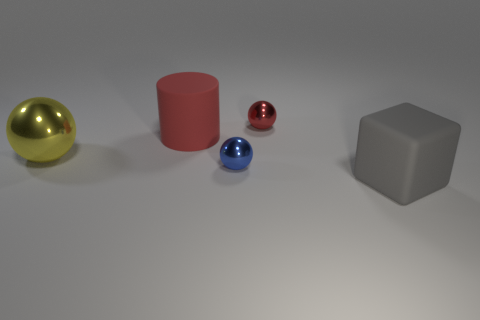There is a tiny object that is the same color as the cylinder; what is it made of?
Offer a very short reply. Metal. Are there any shiny balls that have the same color as the big rubber cylinder?
Keep it short and to the point. Yes. There is a large matte thing behind the yellow metallic sphere; what color is it?
Offer a terse response. Red. Is there a block that is on the right side of the metal sphere behind the rubber cylinder?
Keep it short and to the point. Yes. How many things are rubber things behind the cube or red rubber cylinders?
Your answer should be compact. 1. There is a tiny object that is to the left of the shiny ball that is on the right side of the small blue ball; what is its material?
Your answer should be very brief. Metal. Are there the same number of red things that are on the left side of the big gray rubber object and balls in front of the big red matte cylinder?
Make the answer very short. Yes. What number of things are either big objects that are to the left of the cube or tiny shiny objects in front of the red cylinder?
Offer a terse response. 3. There is a object that is in front of the big yellow metal object and to the left of the gray block; what material is it made of?
Ensure brevity in your answer.  Metal. There is a rubber thing that is on the right side of the small ball that is in front of the metal object that is on the right side of the small blue metal thing; what is its size?
Provide a succinct answer. Large. 